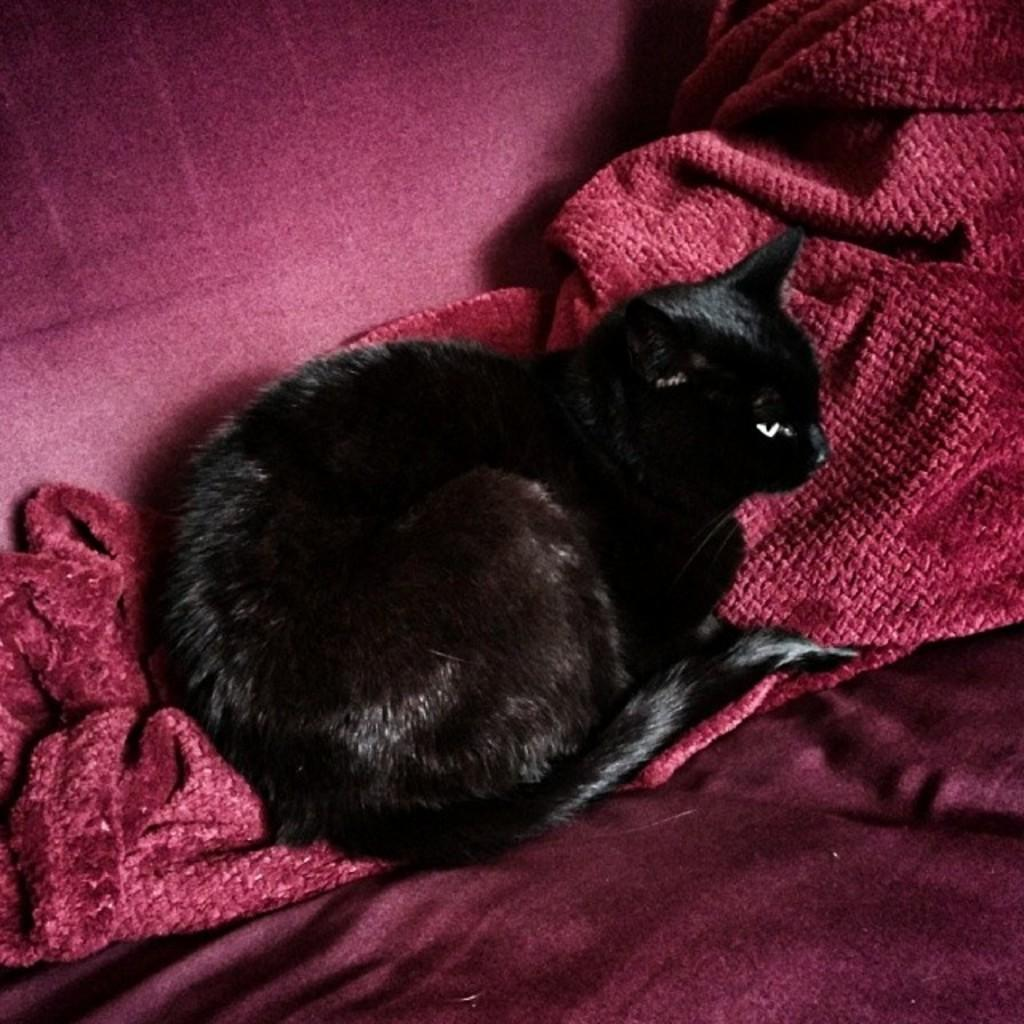What type of animal is present in the image? There is a cat in the image. What is the cat laying on? The cat is laying on a cloth. What type of comb is the cat using to style its fur in the image? There is no comb present in the image, and the cat is not using any tool to style its fur. 